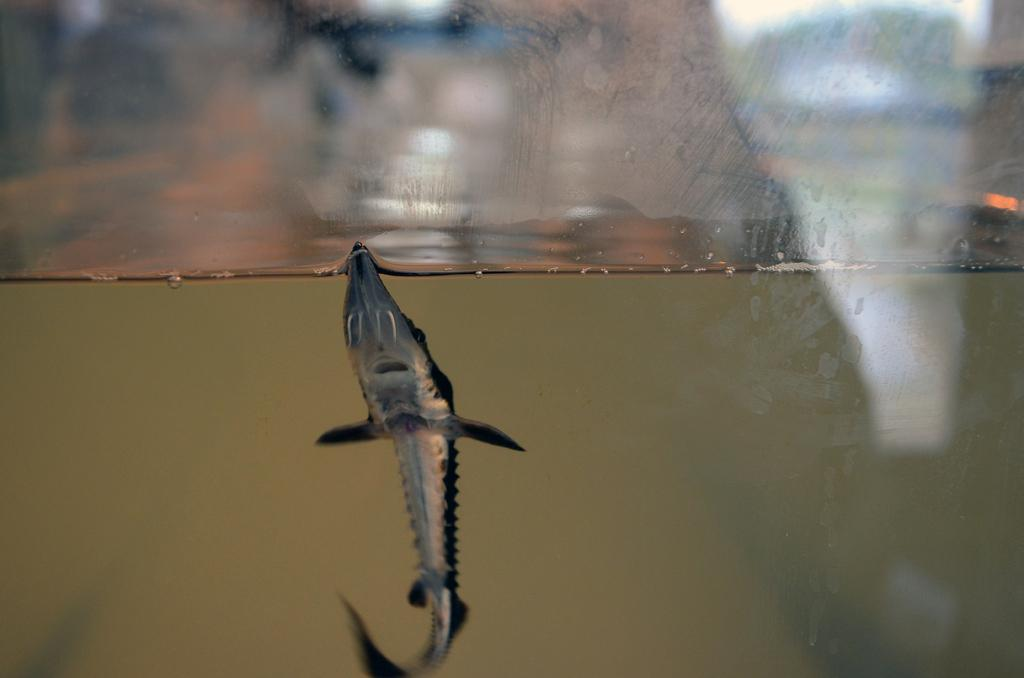What type of animal is in the image? There is a fish in the image. Where is the fish located? The fish is in an aquarium. What is the primary element surrounding the fish? There is water visible in the image. What type of behavior can be observed in the downtown area in the image? There is no downtown area present in the image; it features a fish in an aquarium. 